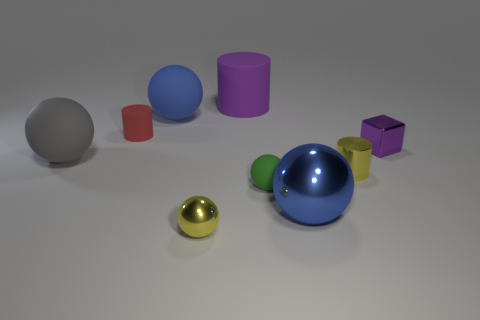Can you describe the lighting and shadows in the scene? The lighting in the image is diffused and soft, coming from above and creating gentle shadows that appear on the ground to the right sides of the objects. This suggests a single, not overly harsh light source, perhaps similar to an overcast sky or a softbox used in photography. 